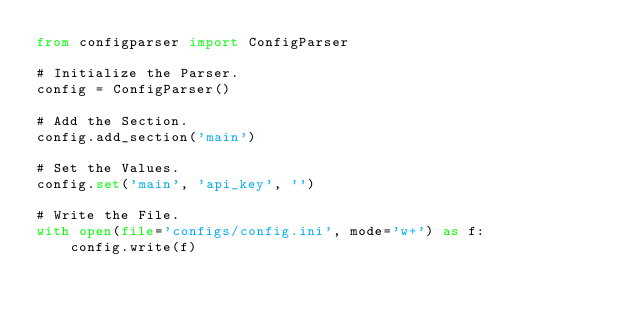Convert code to text. <code><loc_0><loc_0><loc_500><loc_500><_Python_>from configparser import ConfigParser

# Initialize the Parser.
config = ConfigParser()

# Add the Section.
config.add_section('main')

# Set the Values.
config.set('main', 'api_key', '')

# Write the File.
with open(file='configs/config.ini', mode='w+') as f:
    config.write(f)
</code> 